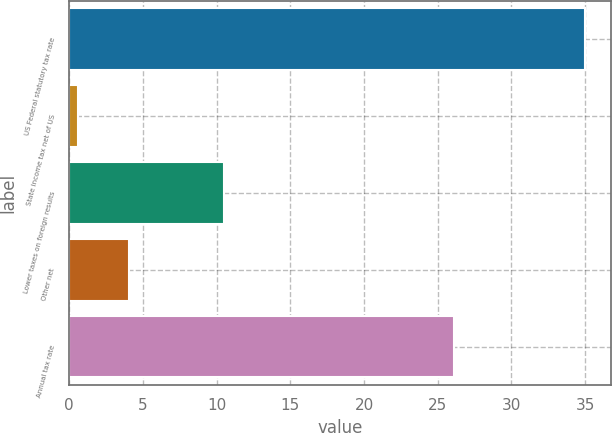Convert chart. <chart><loc_0><loc_0><loc_500><loc_500><bar_chart><fcel>US Federal statutory tax rate<fcel>State income tax net of US<fcel>Lower taxes on foreign results<fcel>Other net<fcel>Annual tax rate<nl><fcel>35<fcel>0.6<fcel>10.5<fcel>4.04<fcel>26.1<nl></chart> 